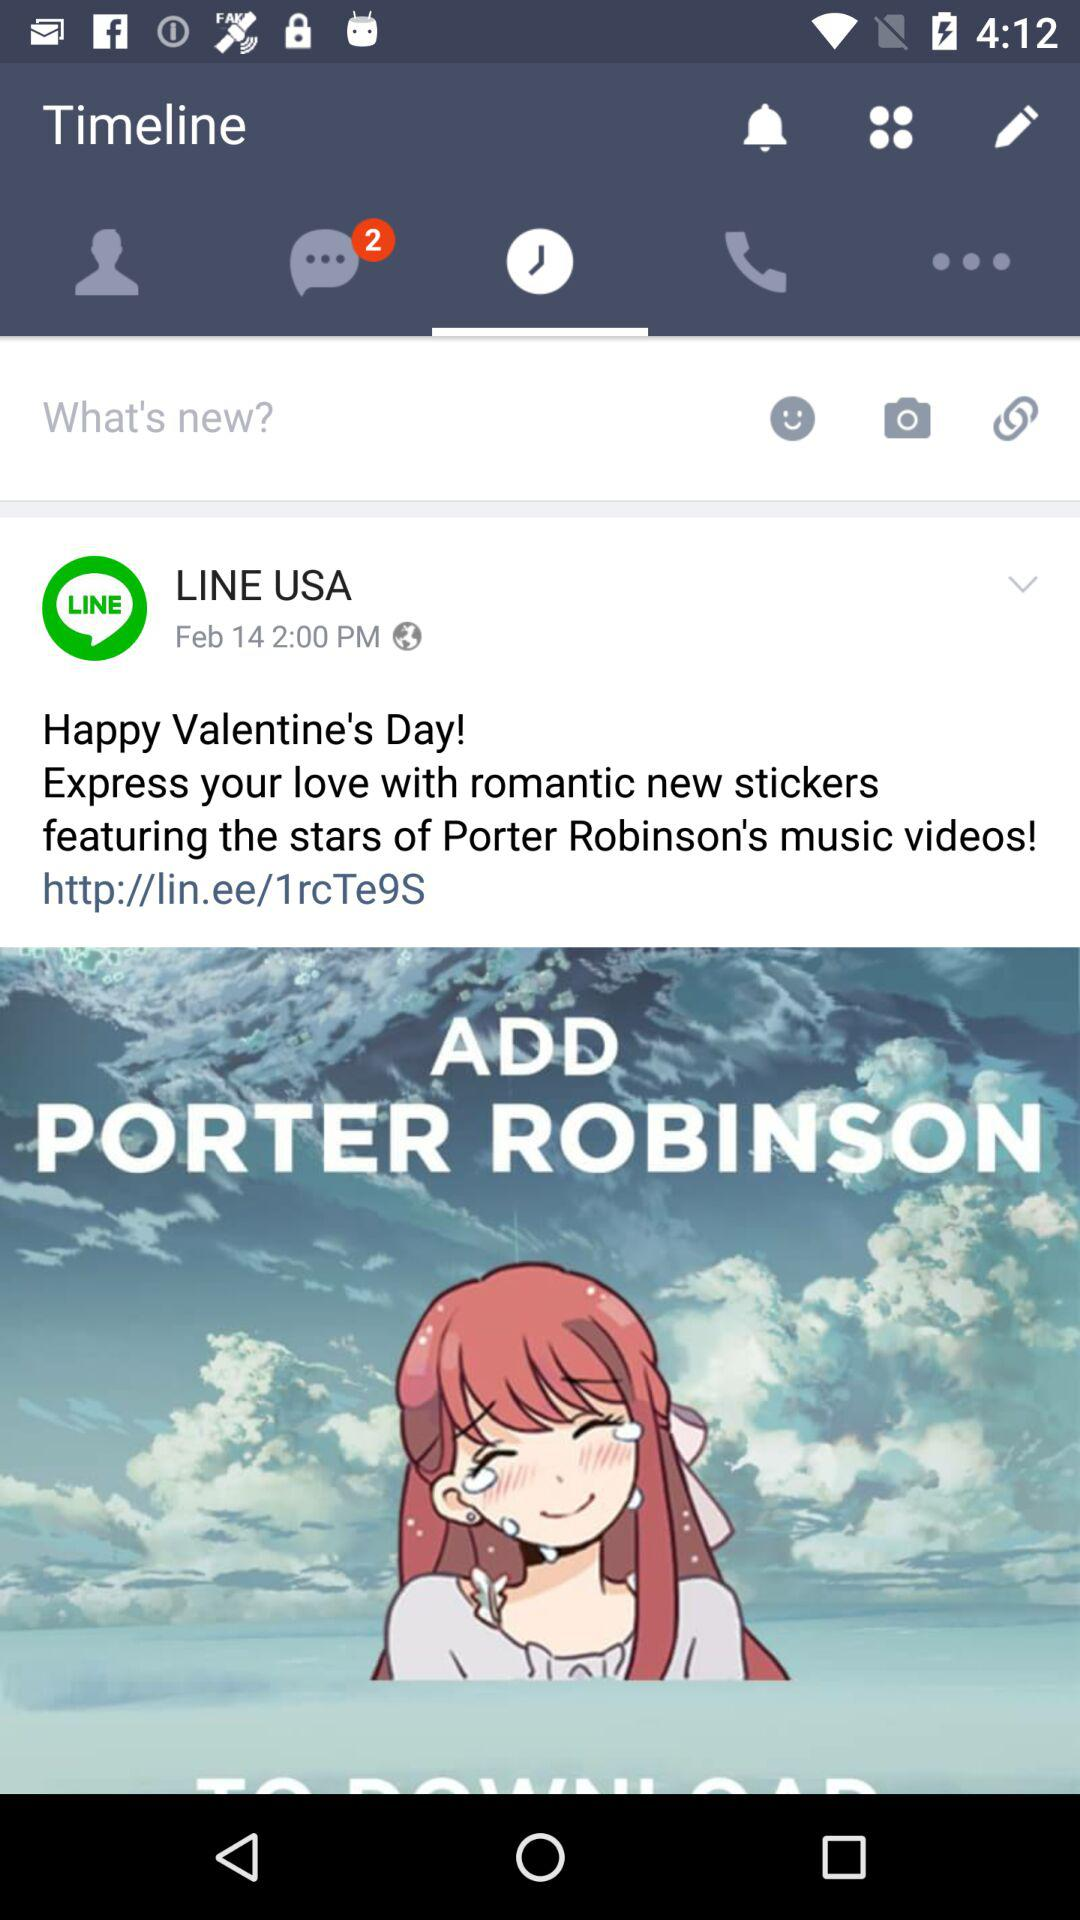Which tab am I on? You are on the "Timeline" tab. 